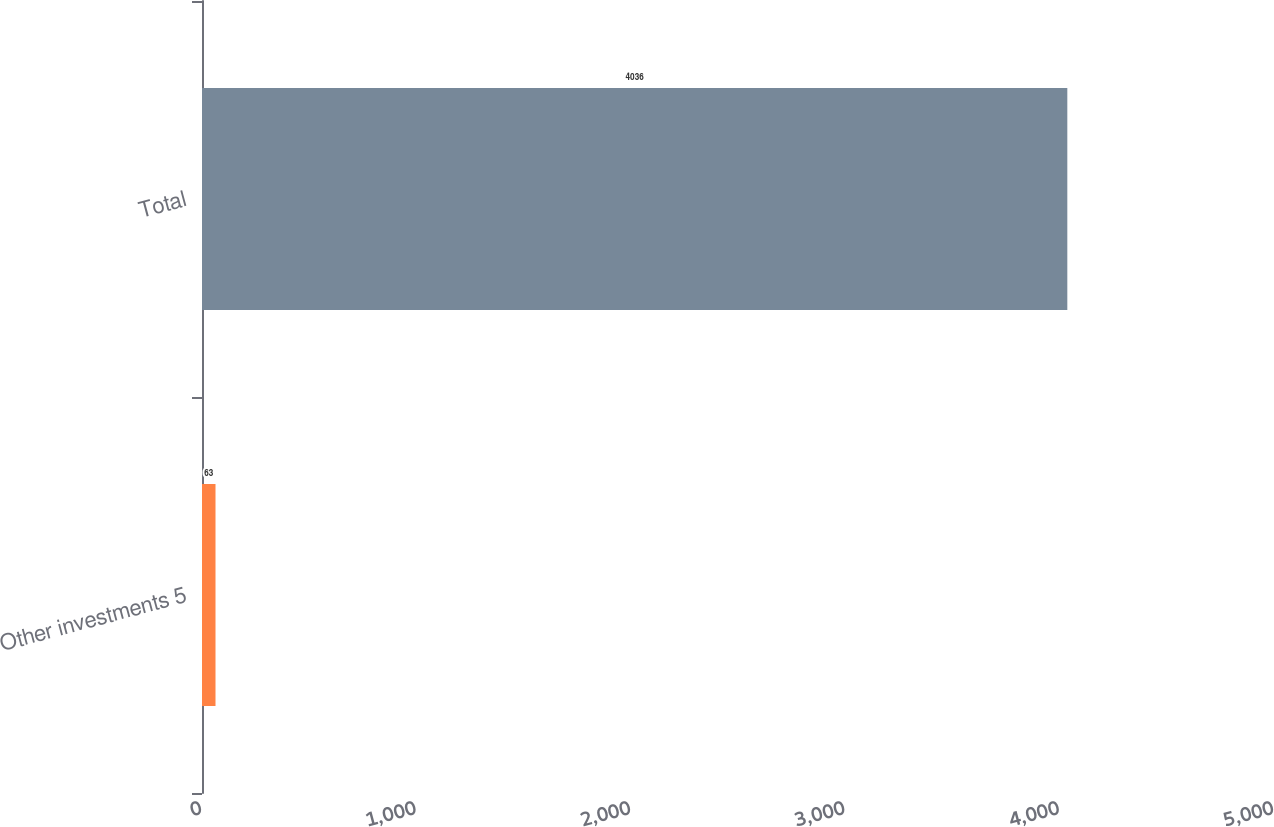Convert chart to OTSL. <chart><loc_0><loc_0><loc_500><loc_500><bar_chart><fcel>Other investments 5<fcel>Total<nl><fcel>63<fcel>4036<nl></chart> 